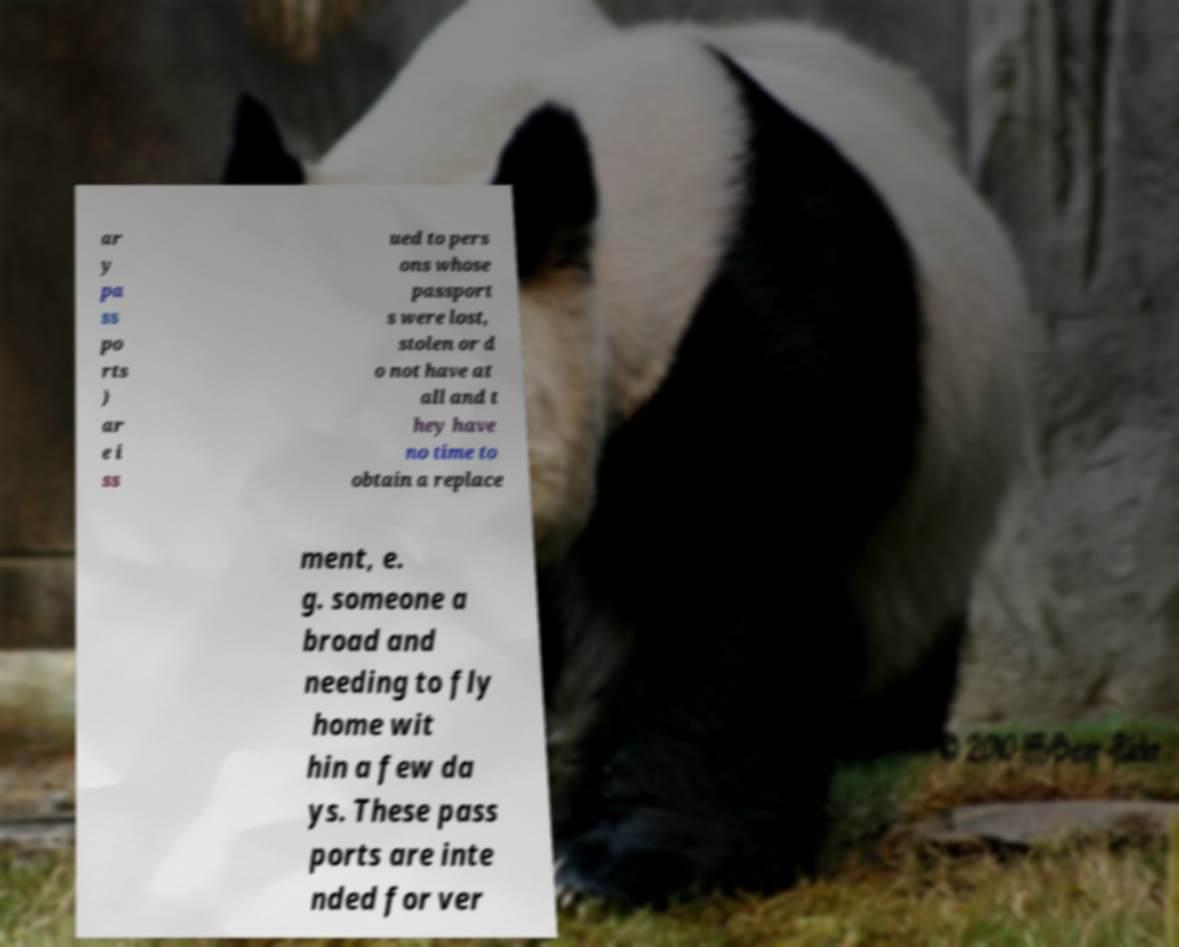There's text embedded in this image that I need extracted. Can you transcribe it verbatim? ar y pa ss po rts ) ar e i ss ued to pers ons whose passport s were lost, stolen or d o not have at all and t hey have no time to obtain a replace ment, e. g. someone a broad and needing to fly home wit hin a few da ys. These pass ports are inte nded for ver 